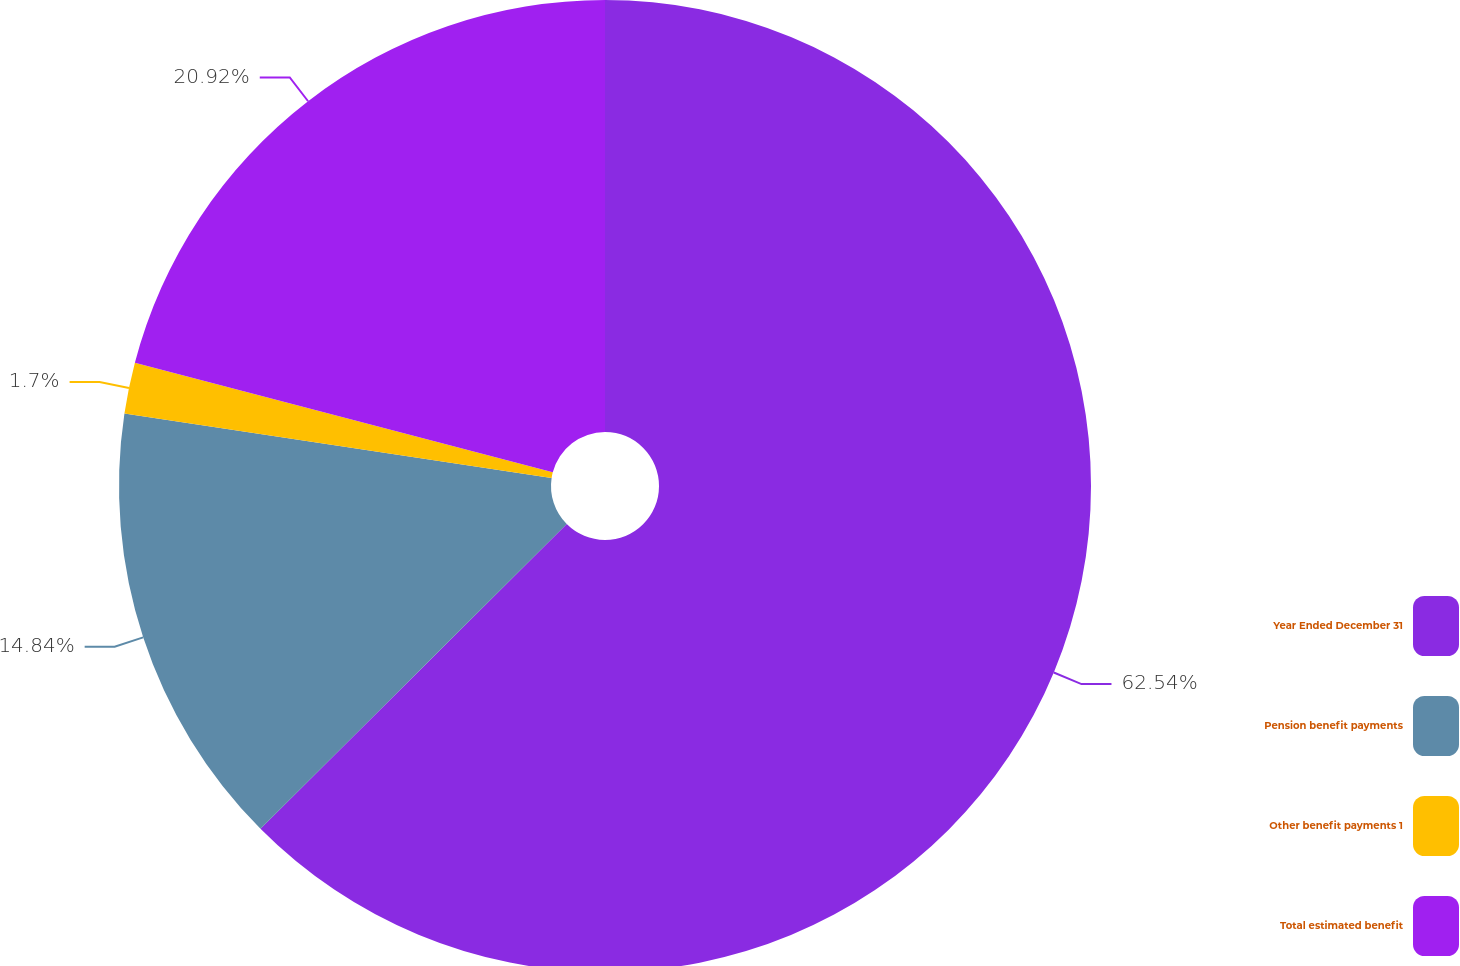<chart> <loc_0><loc_0><loc_500><loc_500><pie_chart><fcel>Year Ended December 31<fcel>Pension benefit payments<fcel>Other benefit payments 1<fcel>Total estimated benefit<nl><fcel>62.54%<fcel>14.84%<fcel>1.7%<fcel>20.92%<nl></chart> 